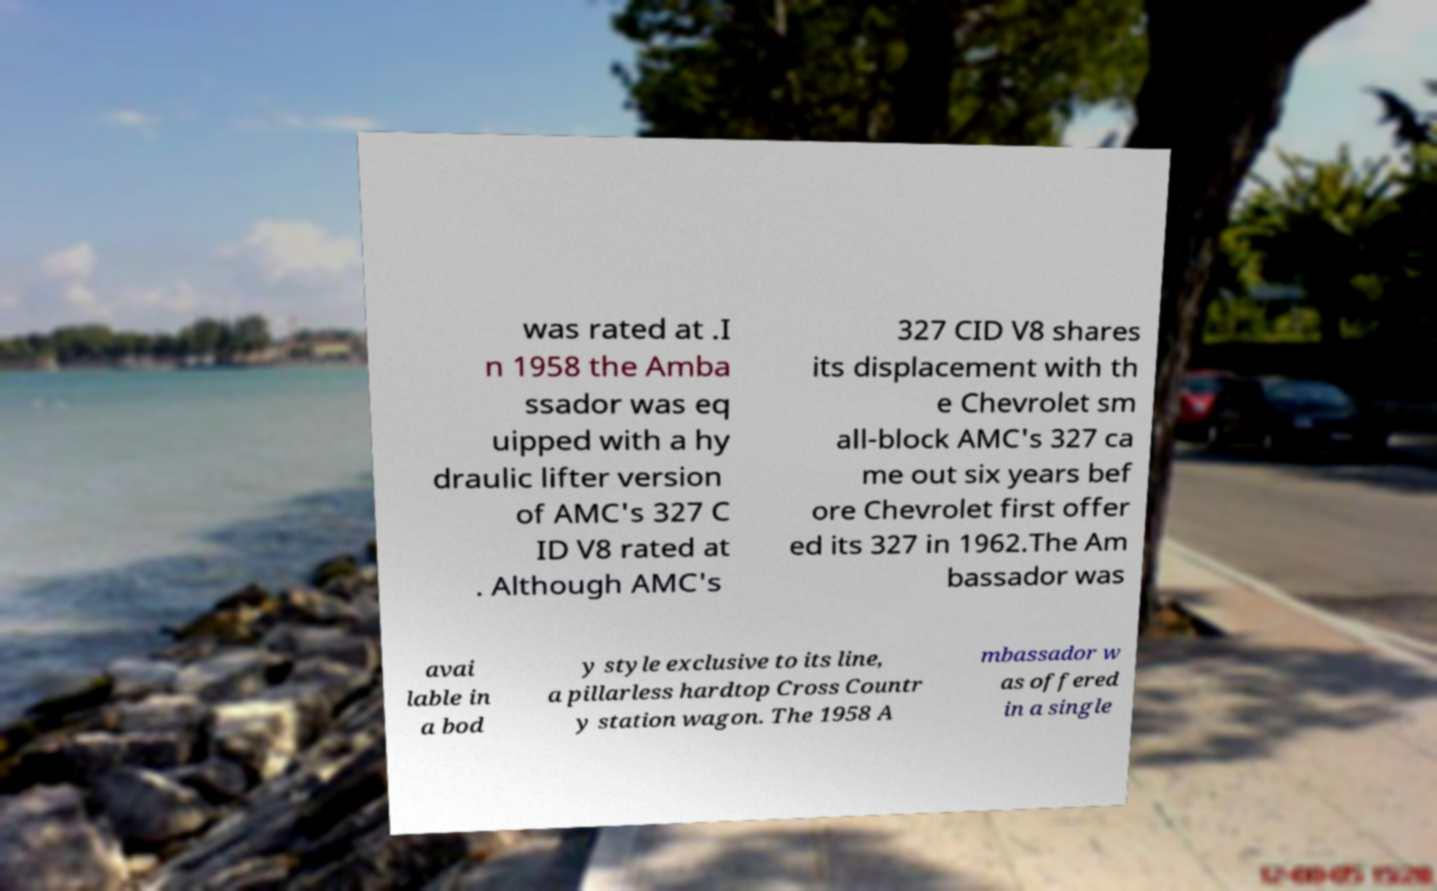Could you assist in decoding the text presented in this image and type it out clearly? was rated at .I n 1958 the Amba ssador was eq uipped with a hy draulic lifter version of AMC's 327 C ID V8 rated at . Although AMC's 327 CID V8 shares its displacement with th e Chevrolet sm all-block AMC's 327 ca me out six years bef ore Chevrolet first offer ed its 327 in 1962.The Am bassador was avai lable in a bod y style exclusive to its line, a pillarless hardtop Cross Countr y station wagon. The 1958 A mbassador w as offered in a single 